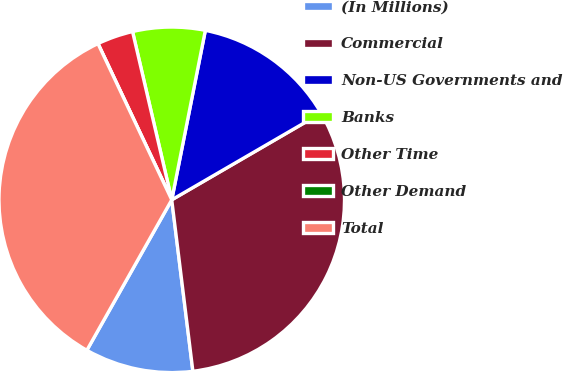Convert chart to OTSL. <chart><loc_0><loc_0><loc_500><loc_500><pie_chart><fcel>(In Millions)<fcel>Commercial<fcel>Non-US Governments and<fcel>Banks<fcel>Other Time<fcel>Other Demand<fcel>Total<nl><fcel>10.13%<fcel>31.42%<fcel>13.51%<fcel>6.76%<fcel>3.38%<fcel>0.0%<fcel>34.8%<nl></chart> 